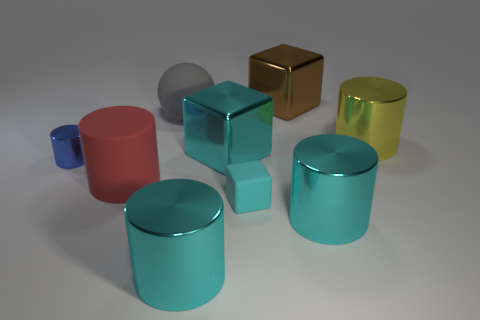Subtract all yellow metallic cylinders. How many cylinders are left? 4 Subtract all blue blocks. How many cyan cylinders are left? 2 Subtract all red cylinders. How many cylinders are left? 4 Subtract all spheres. How many objects are left? 8 Subtract 1 spheres. How many spheres are left? 0 Subtract all purple blocks. Subtract all purple cylinders. How many blocks are left? 3 Subtract all big spheres. Subtract all large cyan cylinders. How many objects are left? 6 Add 5 big gray objects. How many big gray objects are left? 6 Add 6 gray matte balls. How many gray matte balls exist? 7 Subtract 0 gray cylinders. How many objects are left? 9 